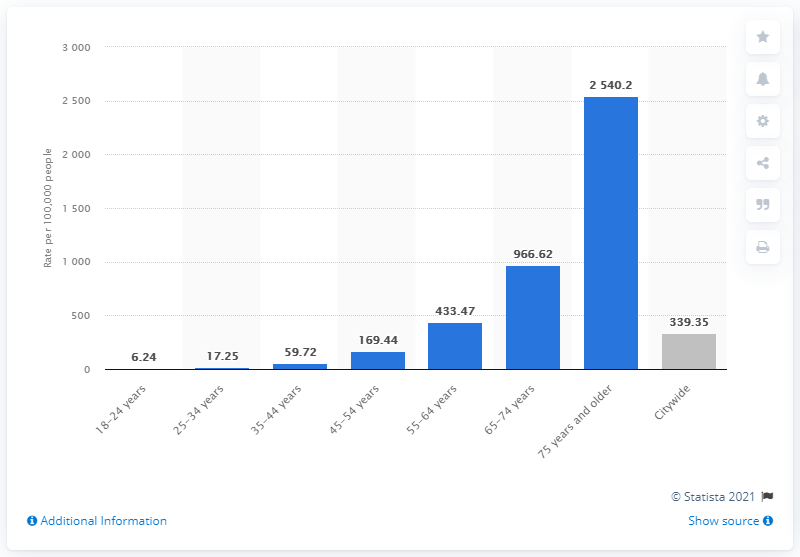Identify some key points in this picture. The group of people with the highest rate of Covid-19 in New York City as of June 20, 2021 was individuals aged 75 years and older. 